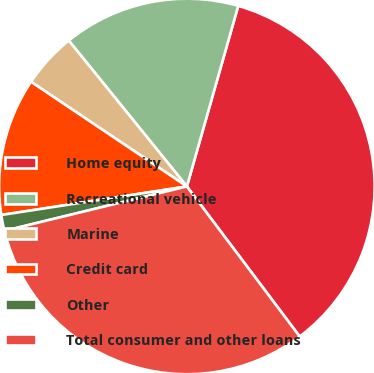Convert chart to OTSL. <chart><loc_0><loc_0><loc_500><loc_500><pie_chart><fcel>Home equity<fcel>Recreational vehicle<fcel>Marine<fcel>Credit card<fcel>Other<fcel>Total consumer and other loans<nl><fcel>35.33%<fcel>15.24%<fcel>4.76%<fcel>11.84%<fcel>1.37%<fcel>31.46%<nl></chart> 